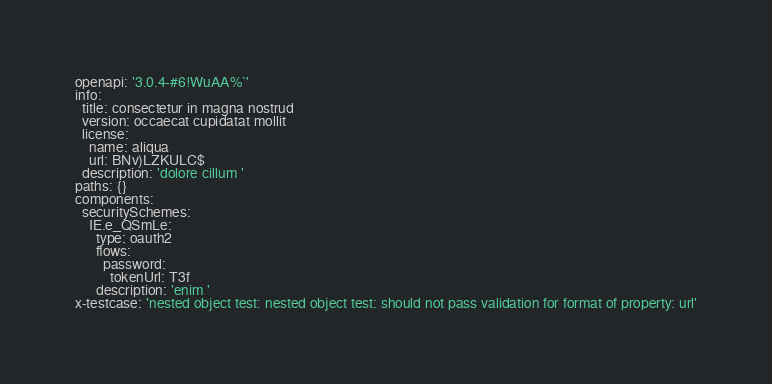<code> <loc_0><loc_0><loc_500><loc_500><_YAML_>openapi: '3.0.4-#6!WuAA%`'
info:
  title: consectetur in magna nostrud
  version: occaecat cupidatat mollit
  license:
    name: aliqua
    url: BNv)LZKULC$
  description: 'dolore cillum '
paths: {}
components:
  securitySchemes:
    IE.e_QSmLe:
      type: oauth2
      flows:
        password:
          tokenUrl: T3f
      description: 'enim '
x-testcase: 'nested object test: nested object test: should not pass validation for format of property: url'
</code> 